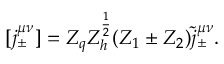<formula> <loc_0><loc_0><loc_500><loc_500>[ j _ { \pm } ^ { \mu \nu } ] = Z _ { q } Z _ { h } ^ { \frac { 1 } { 2 } } ( Z _ { 1 } \pm Z _ { 2 } ) \tilde { j } _ { \pm } ^ { \mu \nu } .</formula> 